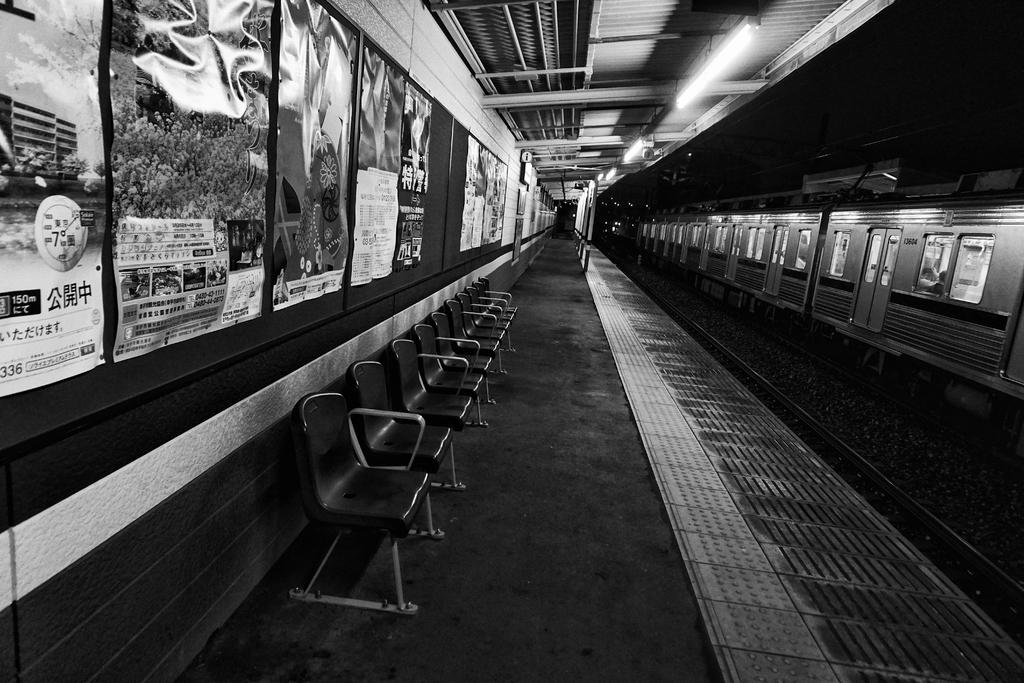What type of transportation infrastructure is depicted in the image? There is a railway station in the image. What is located on the tracks near the railway station? There is a train on the tracks in the image. What type of seating is available in the railway station? There are chairs in the image. What decorative elements can be seen on the walls of the railway station? There are banners present on the walls in the image. Can you tell me how many cars are parked in the image? There are no cars present in the image; it features a railway station and a train on the tracks. What type of trail can be seen leading away from the railway station? There is no trail visible in the image; it focuses on the railway station and the train on the tracks. 